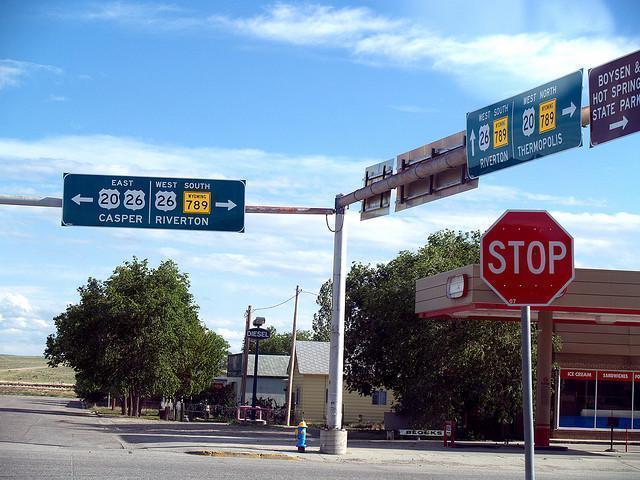What building does the diesel sign most likely foreshadow?
Indicate the correct response and explain using: 'Answer: answer
Rationale: rationale.'
Options: Grocery store, school, gas station, train station. Answer: gas station.
Rationale: Generally that type of fossil fuel is found at a gas station. 